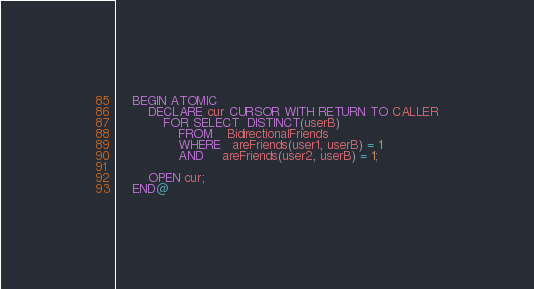Convert code to text. <code><loc_0><loc_0><loc_500><loc_500><_SQL_>    BEGIN ATOMIC
        DECLARE cur CURSOR WITH RETURN TO CALLER
            FOR SELECT  DISTINCT(userB) 
                FROM    BidirectionalFriends
                WHERE   areFriends(user1, userB) = 1  
                AND     areFriends(user2, userB) = 1;

        OPEN cur;
    END@</code> 